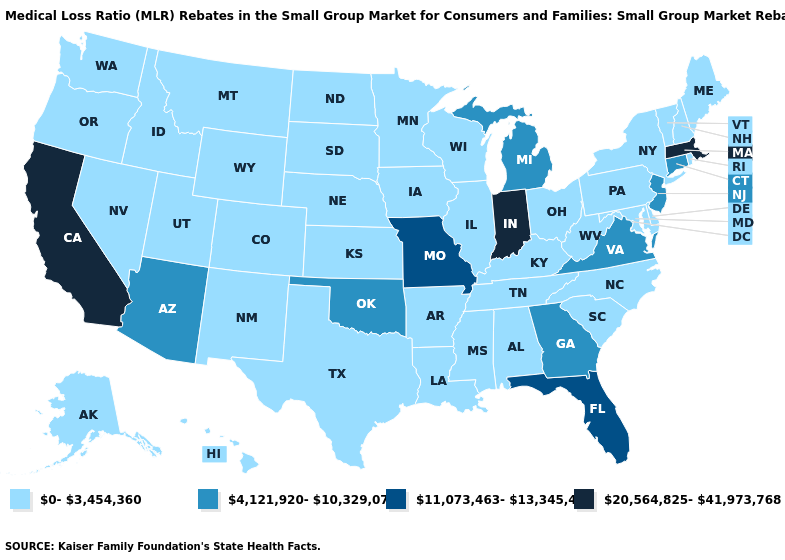What is the lowest value in the MidWest?
Write a very short answer. 0-3,454,360. Name the states that have a value in the range 20,564,825-41,973,768?
Be succinct. California, Indiana, Massachusetts. Does the first symbol in the legend represent the smallest category?
Short answer required. Yes. What is the value of Nevada?
Give a very brief answer. 0-3,454,360. Does Delaware have the same value as Indiana?
Write a very short answer. No. Does California have the highest value in the West?
Short answer required. Yes. Which states have the lowest value in the USA?
Concise answer only. Alabama, Alaska, Arkansas, Colorado, Delaware, Hawaii, Idaho, Illinois, Iowa, Kansas, Kentucky, Louisiana, Maine, Maryland, Minnesota, Mississippi, Montana, Nebraska, Nevada, New Hampshire, New Mexico, New York, North Carolina, North Dakota, Ohio, Oregon, Pennsylvania, Rhode Island, South Carolina, South Dakota, Tennessee, Texas, Utah, Vermont, Washington, West Virginia, Wisconsin, Wyoming. Name the states that have a value in the range 0-3,454,360?
Give a very brief answer. Alabama, Alaska, Arkansas, Colorado, Delaware, Hawaii, Idaho, Illinois, Iowa, Kansas, Kentucky, Louisiana, Maine, Maryland, Minnesota, Mississippi, Montana, Nebraska, Nevada, New Hampshire, New Mexico, New York, North Carolina, North Dakota, Ohio, Oregon, Pennsylvania, Rhode Island, South Carolina, South Dakota, Tennessee, Texas, Utah, Vermont, Washington, West Virginia, Wisconsin, Wyoming. Does New Mexico have a higher value than Delaware?
Quick response, please. No. What is the highest value in states that border Mississippi?
Be succinct. 0-3,454,360. What is the value of North Dakota?
Give a very brief answer. 0-3,454,360. What is the value of Connecticut?
Be succinct. 4,121,920-10,329,073. What is the value of Florida?
Answer briefly. 11,073,463-13,345,485. Does Wyoming have the lowest value in the West?
Short answer required. Yes. Does the map have missing data?
Be succinct. No. 